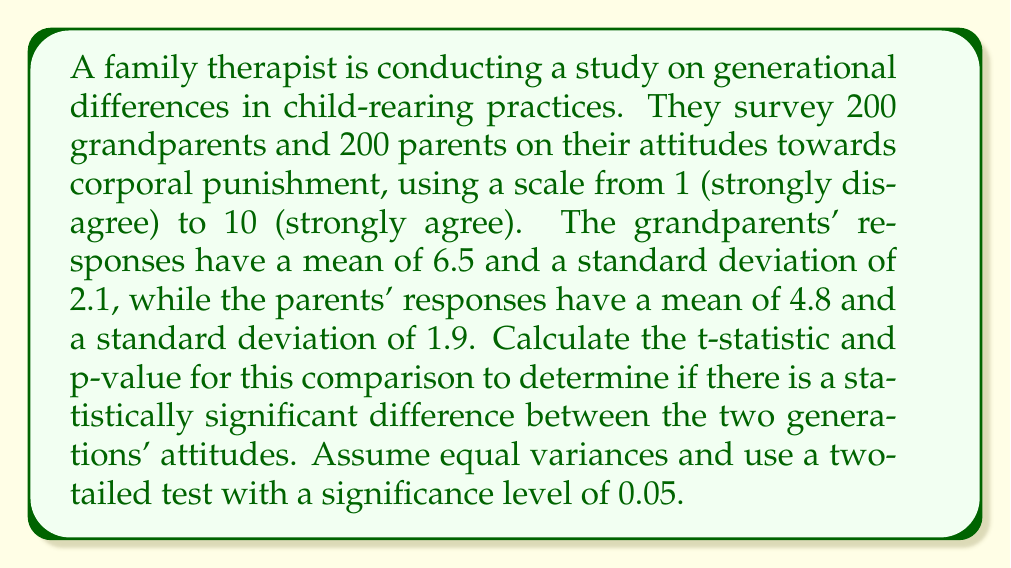Help me with this question. To determine if there is a statistically significant difference between the two generations' attitudes towards corporal punishment, we need to perform an independent samples t-test. We'll follow these steps:

1. Calculate the pooled standard deviation:
   $$s_p = \sqrt{\frac{(n_1 - 1)s_1^2 + (n_2 - 1)s_2^2}{n_1 + n_2 - 2}}$$
   Where $n_1 = n_2 = 200$, $s_1 = 2.1$, and $s_2 = 1.9$

   $$s_p = \sqrt{\frac{(200 - 1)(2.1)^2 + (200 - 1)(1.9)^2}{200 + 200 - 2}}$$
   $$s_p = \sqrt{\frac{873.39 + 717.61}{398}} = \sqrt{4.00} = 2.00$$

2. Calculate the t-statistic:
   $$t = \frac{\bar{x}_1 - \bar{x}_2}{s_p\sqrt{\frac{2}{n}}}$$
   Where $\bar{x}_1 = 6.5$, $\bar{x}_2 = 4.8$, and $n = 200$

   $$t = \frac{6.5 - 4.8}{2.00\sqrt{\frac{2}{200}}} = \frac{1.7}{0.2} = 8.5$$

3. Calculate degrees of freedom:
   $df = n_1 + n_2 - 2 = 200 + 200 - 2 = 398$

4. Find the critical t-value for a two-tailed test with $\alpha = 0.05$ and $df = 398$:
   $t_{crit} \approx 1.966$ (from t-distribution table)

5. Calculate the p-value:
   Since the calculated t-statistic (8.5) is greater than the critical t-value (1.966), we know the p-value will be less than 0.05. Using a t-distribution calculator or table, we find:
   $p < 0.0001$

6. Interpret the results:
   Since $p < 0.0001 < 0.05$, we reject the null hypothesis and conclude that there is a statistically significant difference between the grandparents' and parents' attitudes towards corporal punishment.
Answer: t-statistic: 8.5
p-value: $p < 0.0001$
There is a statistically significant difference between the two generations' attitudes towards corporal punishment. 